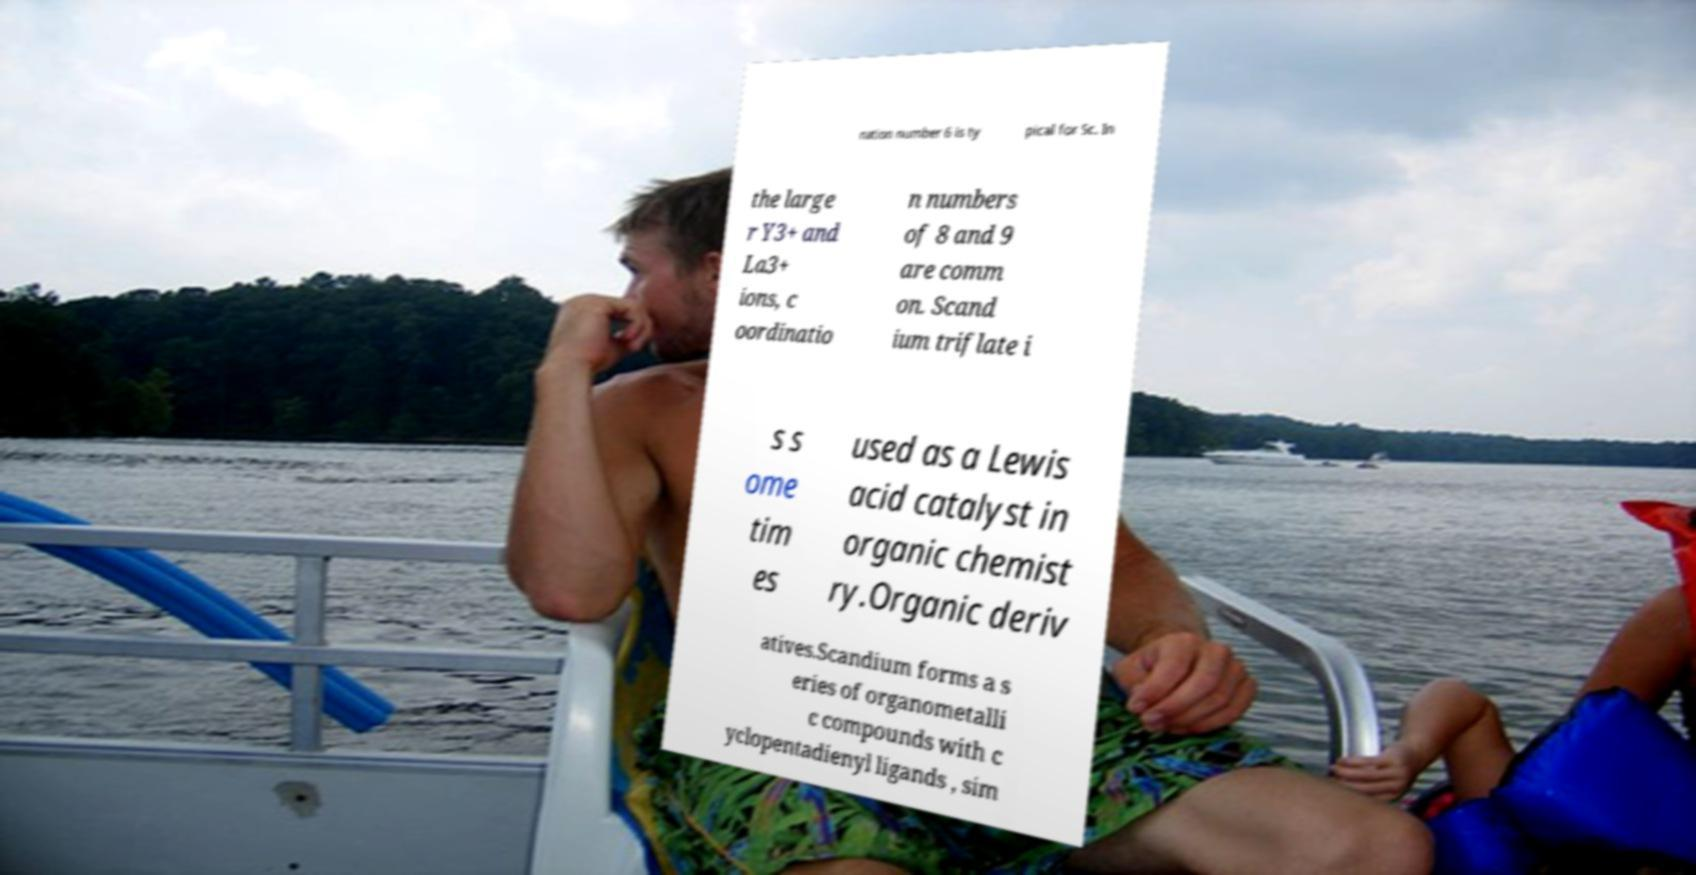I need the written content from this picture converted into text. Can you do that? nation number 6 is ty pical for Sc. In the large r Y3+ and La3+ ions, c oordinatio n numbers of 8 and 9 are comm on. Scand ium triflate i s s ome tim es used as a Lewis acid catalyst in organic chemist ry.Organic deriv atives.Scandium forms a s eries of organometalli c compounds with c yclopentadienyl ligands , sim 